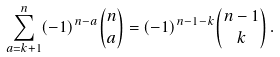Convert formula to latex. <formula><loc_0><loc_0><loc_500><loc_500>\sum _ { a = k + 1 } ^ { n } ( - 1 ) ^ { n - a } { n \choose a } = ( - 1 ) ^ { n - 1 - k } { n - 1 \choose k } \, .</formula> 